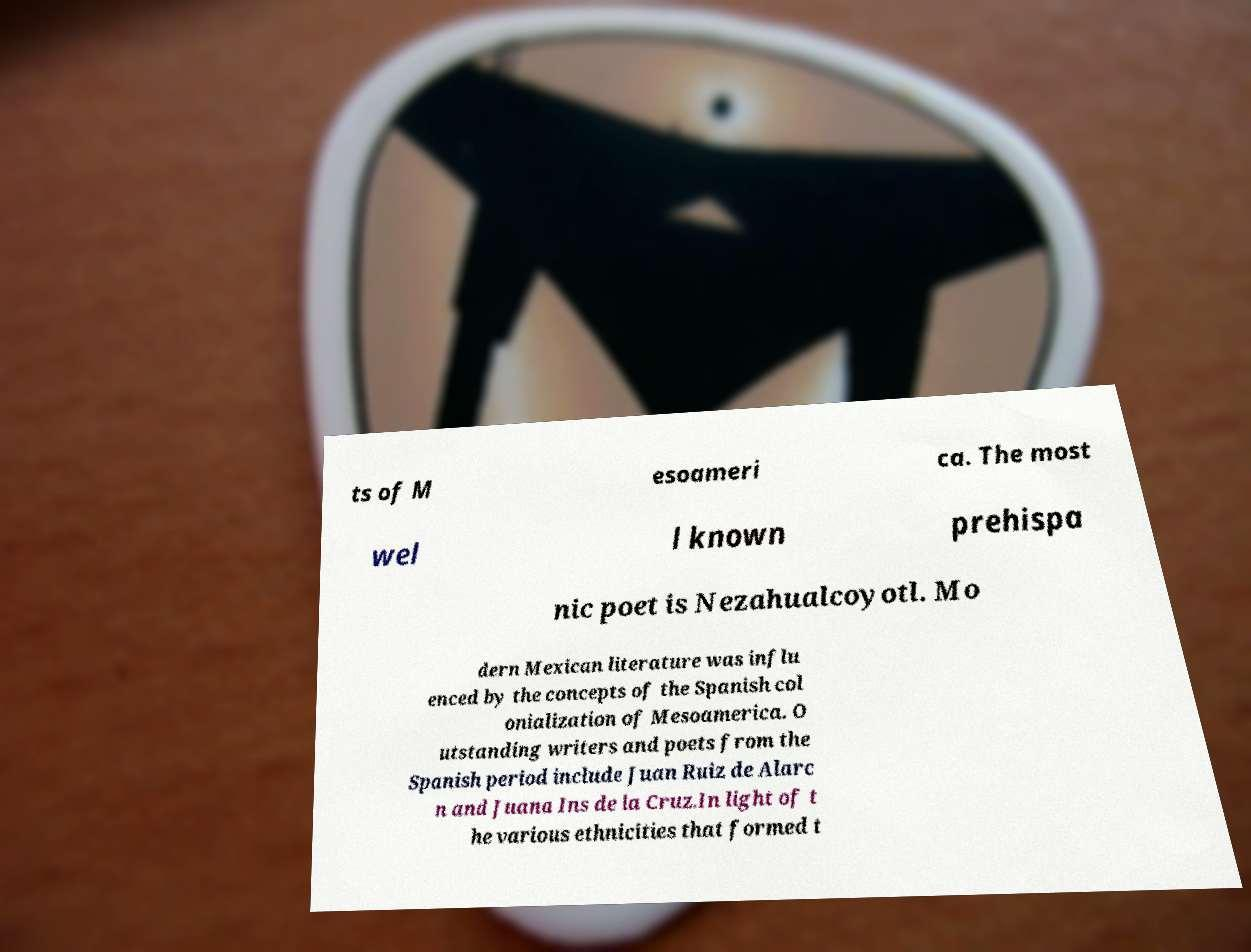Please identify and transcribe the text found in this image. ts of M esoameri ca. The most wel l known prehispa nic poet is Nezahualcoyotl. Mo dern Mexican literature was influ enced by the concepts of the Spanish col onialization of Mesoamerica. O utstanding writers and poets from the Spanish period include Juan Ruiz de Alarc n and Juana Ins de la Cruz.In light of t he various ethnicities that formed t 